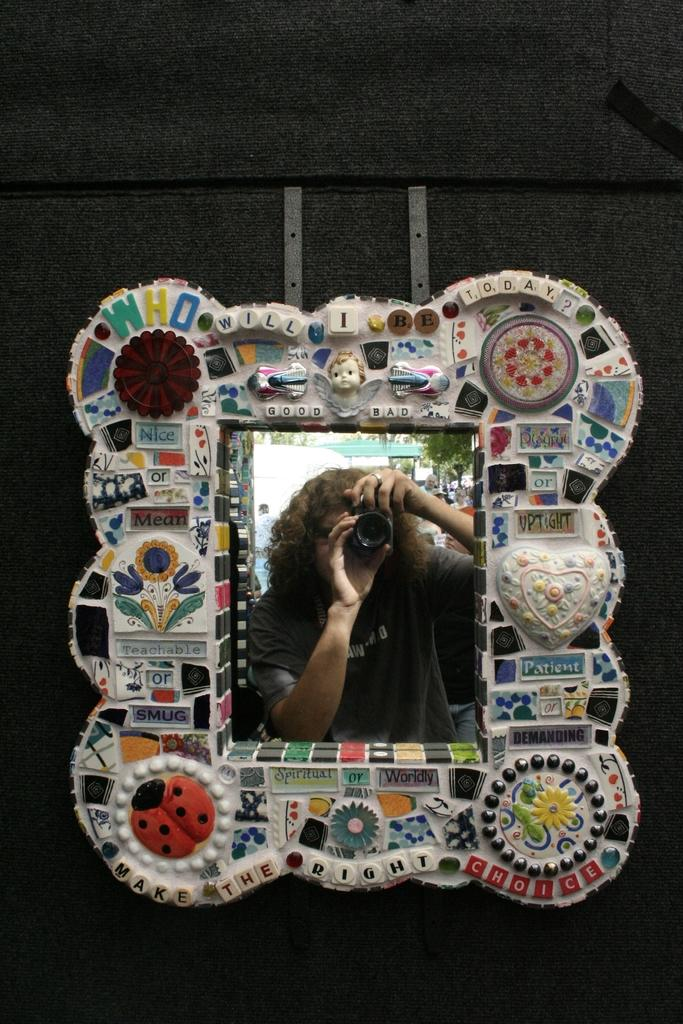What is hanging on the wall in the image? There is a photo frame on the wall in the image. What is inside the photo frame? The photo frame contains a picture of a person. What is the person in the photo doing? The person in the photo is holding a camera with her hands. How does the person in the photo get the attention of the camera? The person in the photo is already holding the camera, so there is no need for them to get the attention of the camera. 